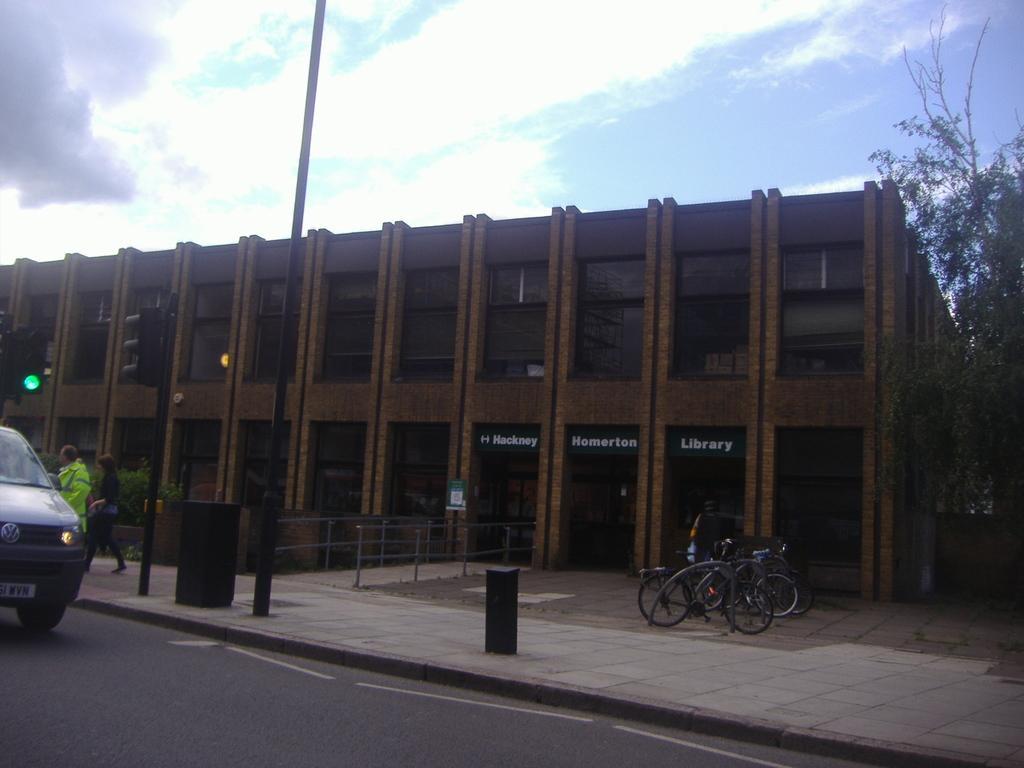Can you describe this image briefly? In this image there is a car on a road and people walking on a footpath and there are poles, beside the footpath there is a pavement on that pavement there is are bicycles and there is a railing, in the background there is a building, trees and the sky. 